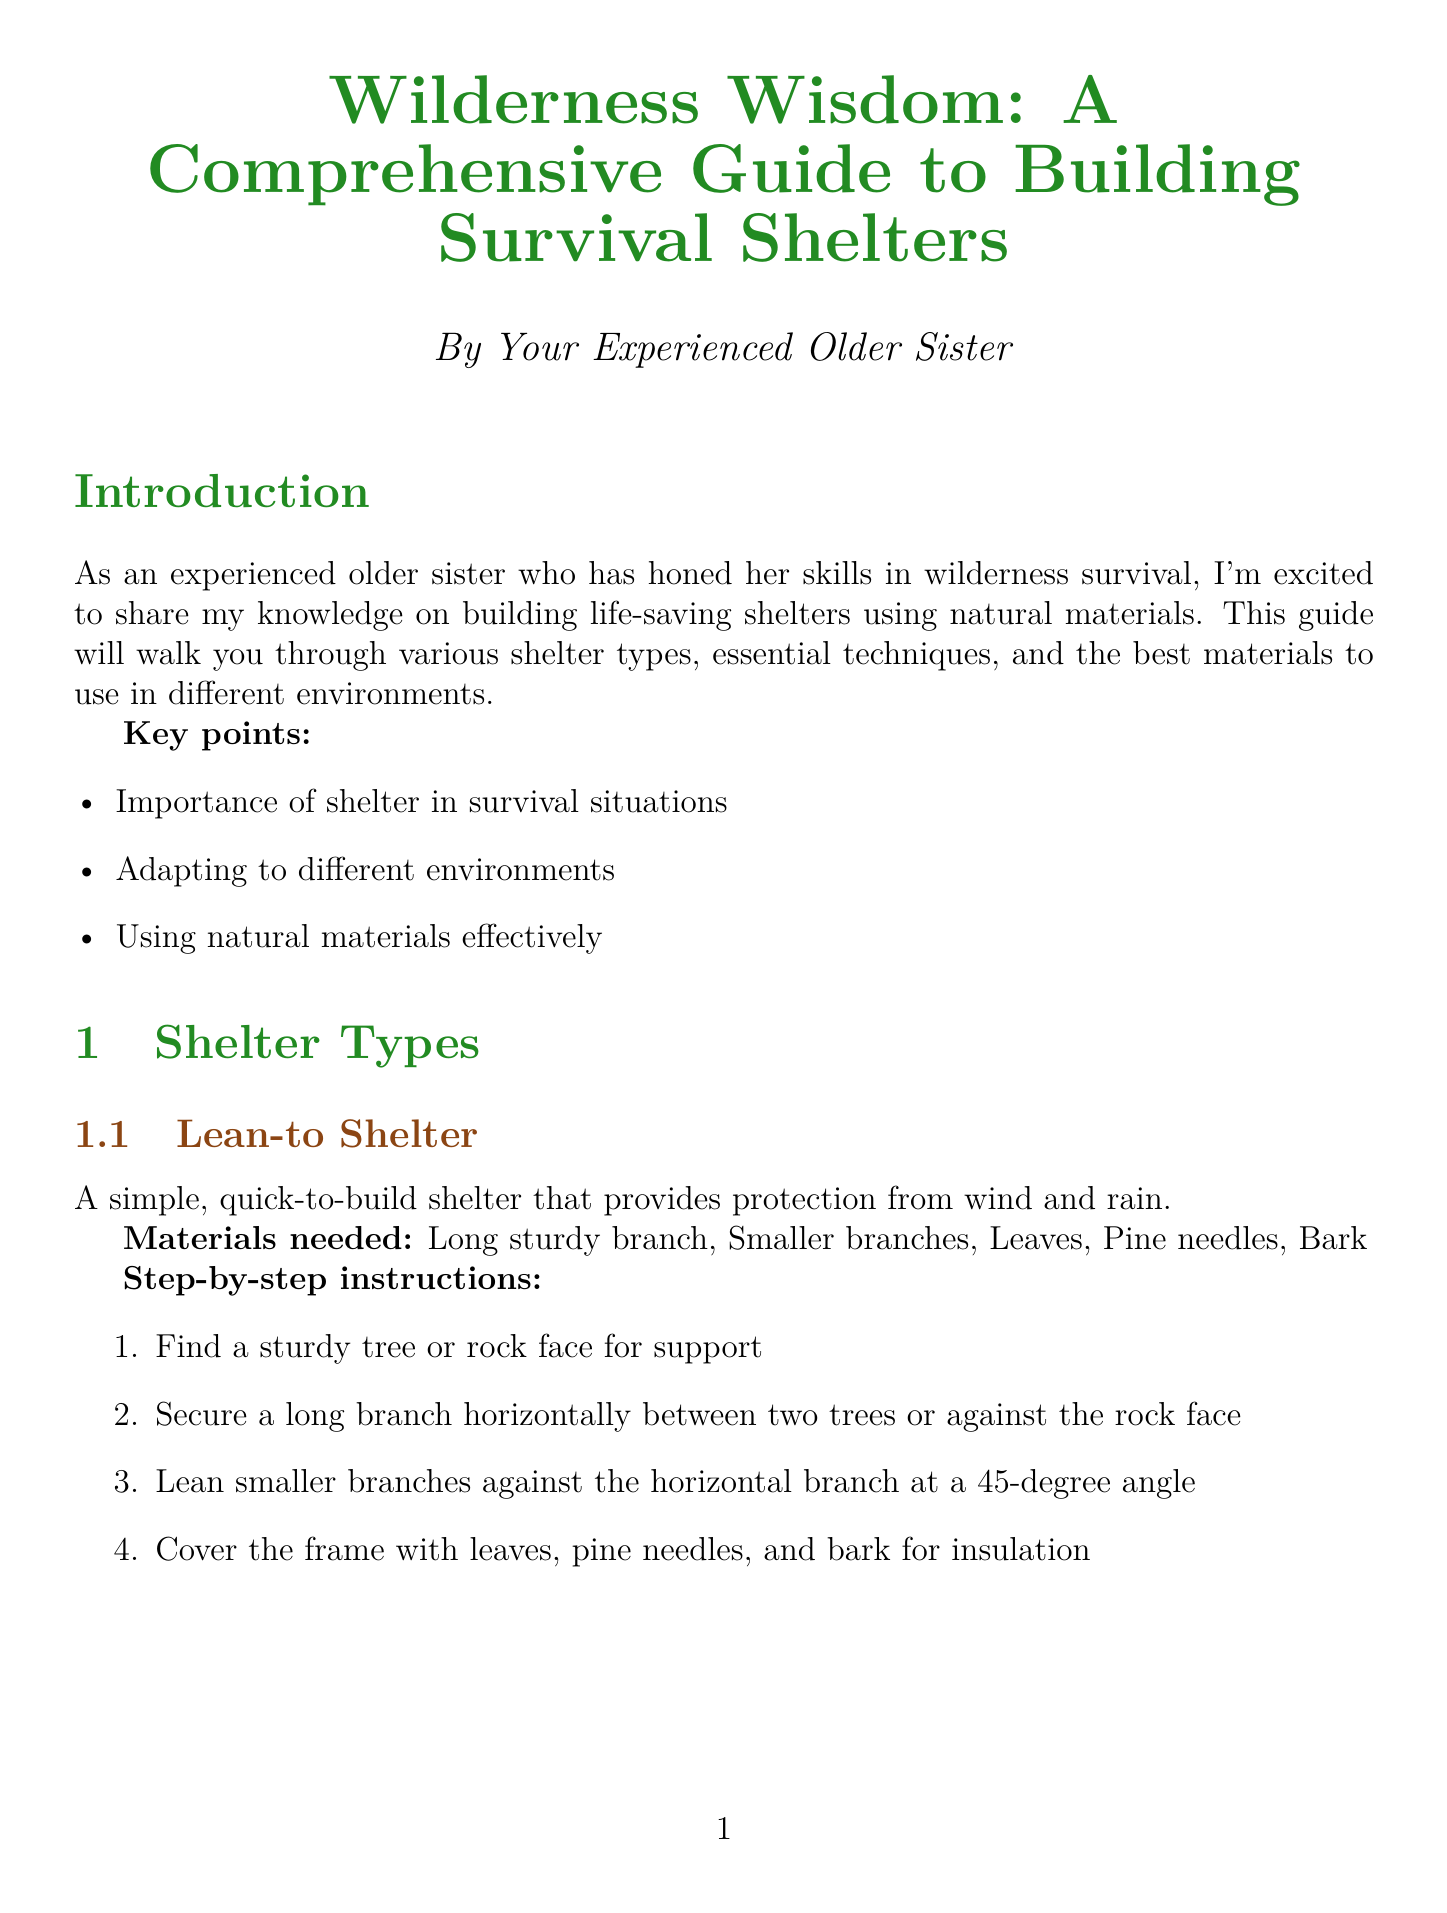What is the title of the manual? The title is explicitly stated at the beginning of the document.
Answer: Wilderness Wisdom: A Comprehensive Guide to Building Survival Shelters How many main types of shelters are described? The document lists the types of shelters talked about.
Answer: 2 What materials are needed for a Lean-to Shelter? The document provides a list of materials specifically needed for this type of shelter.
Answer: Long sturdy branch, Smaller branches, Leaves, Pine needles, Bark What is the first step in building a Debris Hut? The document outlines the step-by-step instructions for constructing this type of shelter.
Answer: Create an A-frame structure using a long branch and shorter support branches What should you pack out when dismantling a shelter? The document advises on responsible practices regarding environmental considerations.
Answer: Any non-natural materials used in construction What is one use of birch bark? The natural materials guide provides several uses for birch bark.
Answer: Waterproof roofing What should you prioritize in your survival strategy according to the conclusion? The conclusion gives final tips for effective survival strategies.
Answer: Shelter building What are two ingredients for Natural Cement Mixing? The advanced techniques section lists the ingredients for creating natural cement.
Answer: Clay, Sand 